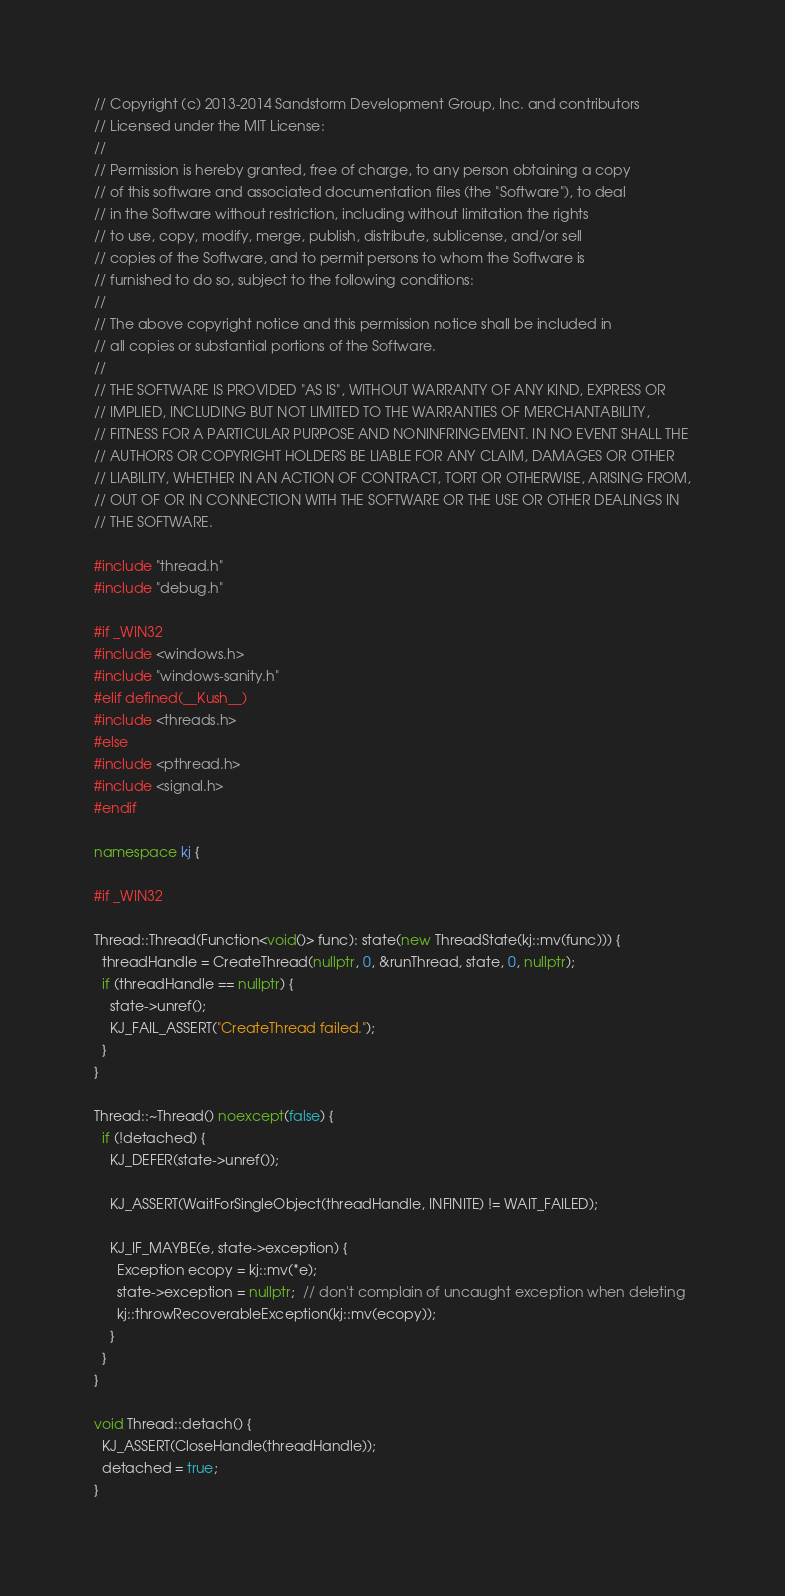<code> <loc_0><loc_0><loc_500><loc_500><_C++_>// Copyright (c) 2013-2014 Sandstorm Development Group, Inc. and contributors
// Licensed under the MIT License:
//
// Permission is hereby granted, free of charge, to any person obtaining a copy
// of this software and associated documentation files (the "Software"), to deal
// in the Software without restriction, including without limitation the rights
// to use, copy, modify, merge, publish, distribute, sublicense, and/or sell
// copies of the Software, and to permit persons to whom the Software is
// furnished to do so, subject to the following conditions:
//
// The above copyright notice and this permission notice shall be included in
// all copies or substantial portions of the Software.
//
// THE SOFTWARE IS PROVIDED "AS IS", WITHOUT WARRANTY OF ANY KIND, EXPRESS OR
// IMPLIED, INCLUDING BUT NOT LIMITED TO THE WARRANTIES OF MERCHANTABILITY,
// FITNESS FOR A PARTICULAR PURPOSE AND NONINFRINGEMENT. IN NO EVENT SHALL THE
// AUTHORS OR COPYRIGHT HOLDERS BE LIABLE FOR ANY CLAIM, DAMAGES OR OTHER
// LIABILITY, WHETHER IN AN ACTION OF CONTRACT, TORT OR OTHERWISE, ARISING FROM,
// OUT OF OR IN CONNECTION WITH THE SOFTWARE OR THE USE OR OTHER DEALINGS IN
// THE SOFTWARE.

#include "thread.h"
#include "debug.h"

#if _WIN32
#include <windows.h>
#include "windows-sanity.h"
#elif defined(__Kush__)
#include <threads.h>
#else
#include <pthread.h>
#include <signal.h>
#endif

namespace kj {

#if _WIN32

Thread::Thread(Function<void()> func): state(new ThreadState(kj::mv(func))) {
  threadHandle = CreateThread(nullptr, 0, &runThread, state, 0, nullptr);
  if (threadHandle == nullptr) {
    state->unref();
    KJ_FAIL_ASSERT("CreateThread failed.");
  }
}

Thread::~Thread() noexcept(false) {
  if (!detached) {
    KJ_DEFER(state->unref());

    KJ_ASSERT(WaitForSingleObject(threadHandle, INFINITE) != WAIT_FAILED);

    KJ_IF_MAYBE(e, state->exception) {
      Exception ecopy = kj::mv(*e);
      state->exception = nullptr;  // don't complain of uncaught exception when deleting
      kj::throwRecoverableException(kj::mv(ecopy));
    }
  }
}

void Thread::detach() {
  KJ_ASSERT(CloseHandle(threadHandle));
  detached = true;
}
</code> 